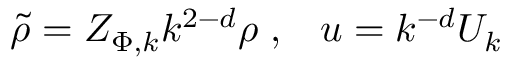<formula> <loc_0><loc_0><loc_500><loc_500>\tilde { \rho } = Z _ { \Phi , k } k ^ { 2 - d } \rho \, , \, u = k ^ { - d } U _ { k }</formula> 